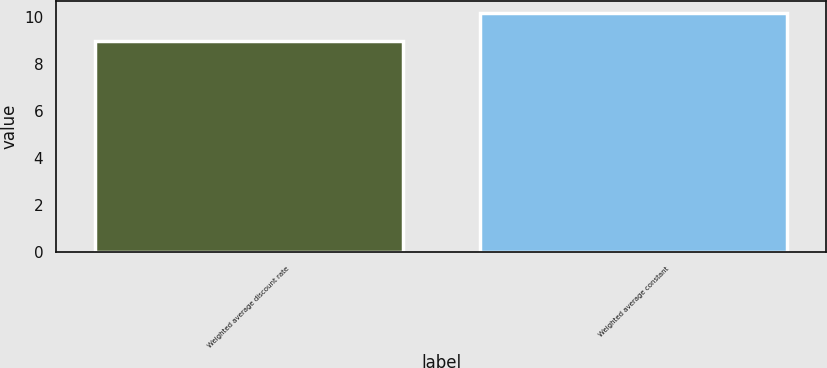<chart> <loc_0><loc_0><loc_500><loc_500><bar_chart><fcel>Weighted average discount rate<fcel>Weighted average constant<nl><fcel>9<fcel>10.2<nl></chart> 